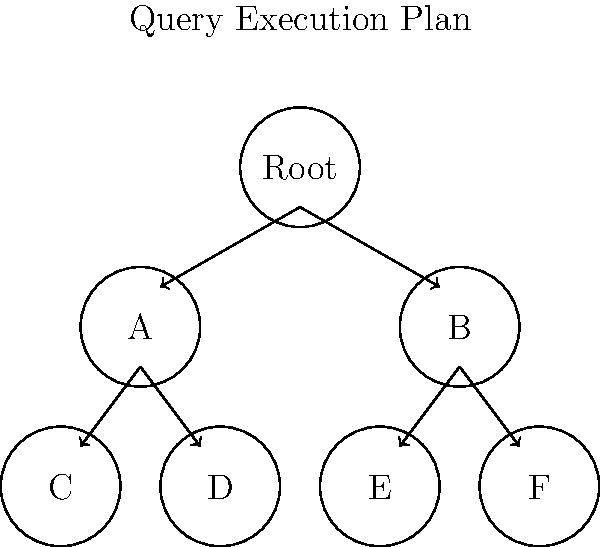In the given query execution plan tree diagram, which node represents the starting point of the execution, and how many child nodes does it have? To answer this question, we need to analyze the structure of the query execution plan tree diagram:

1. Identify the root node:
   - The topmost node in the tree is labeled "Root".
   - In query execution plans, the root node represents the starting point of the execution.

2. Count the child nodes of the root:
   - The root node has two arrows pointing downwards.
   - These arrows connect to two nodes labeled "A" and "B".
   - Each of these arrows represents a child node of the root.

3. Understand the significance:
   - In query execution plans, child nodes represent operations or steps that are executed as part of the query.
   - The number of child nodes indicates how many parallel or sequential operations are directly initiated by the root operation.

4. Formulate the answer:
   - The starting point (root) is the node labeled "Root".
   - It has exactly 2 child nodes.

This tree structure suggests that the query execution begins with the root operation, which then splits into two main branches of execution.
Answer: Root node, 2 child nodes 